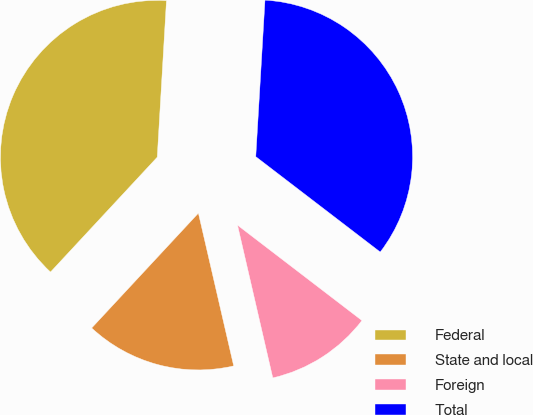Convert chart. <chart><loc_0><loc_0><loc_500><loc_500><pie_chart><fcel>Federal<fcel>State and local<fcel>Foreign<fcel>Total<nl><fcel>39.02%<fcel>15.53%<fcel>10.98%<fcel>34.47%<nl></chart> 